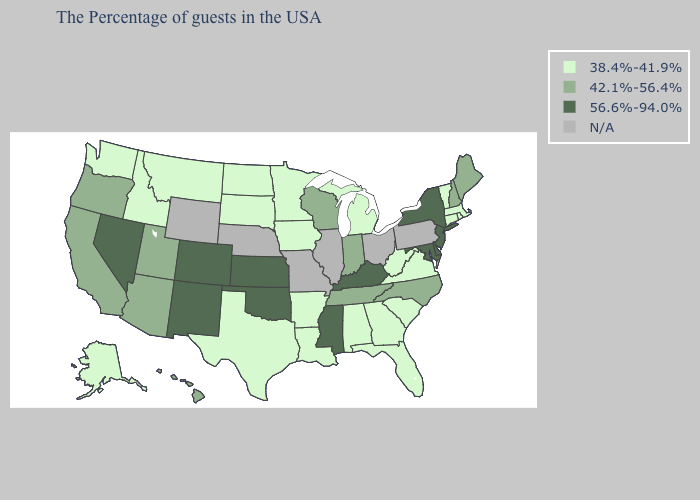What is the value of Nevada?
Short answer required. 56.6%-94.0%. Name the states that have a value in the range N/A?
Be succinct. Pennsylvania, Ohio, Illinois, Missouri, Nebraska, Wyoming. Which states hav the highest value in the West?
Write a very short answer. Colorado, New Mexico, Nevada. What is the lowest value in the USA?
Give a very brief answer. 38.4%-41.9%. Name the states that have a value in the range 56.6%-94.0%?
Concise answer only. New York, New Jersey, Delaware, Maryland, Kentucky, Mississippi, Kansas, Oklahoma, Colorado, New Mexico, Nevada. What is the lowest value in states that border Vermont?
Keep it brief. 38.4%-41.9%. What is the value of Nebraska?
Write a very short answer. N/A. Name the states that have a value in the range 38.4%-41.9%?
Write a very short answer. Massachusetts, Rhode Island, Vermont, Connecticut, Virginia, South Carolina, West Virginia, Florida, Georgia, Michigan, Alabama, Louisiana, Arkansas, Minnesota, Iowa, Texas, South Dakota, North Dakota, Montana, Idaho, Washington, Alaska. Name the states that have a value in the range 42.1%-56.4%?
Keep it brief. Maine, New Hampshire, North Carolina, Indiana, Tennessee, Wisconsin, Utah, Arizona, California, Oregon, Hawaii. What is the value of Idaho?
Answer briefly. 38.4%-41.9%. What is the lowest value in the Northeast?
Write a very short answer. 38.4%-41.9%. Among the states that border Colorado , which have the lowest value?
Be succinct. Utah, Arizona. Which states hav the highest value in the West?
Short answer required. Colorado, New Mexico, Nevada. Name the states that have a value in the range 42.1%-56.4%?
Be succinct. Maine, New Hampshire, North Carolina, Indiana, Tennessee, Wisconsin, Utah, Arizona, California, Oregon, Hawaii. Among the states that border Virginia , does Tennessee have the highest value?
Give a very brief answer. No. 